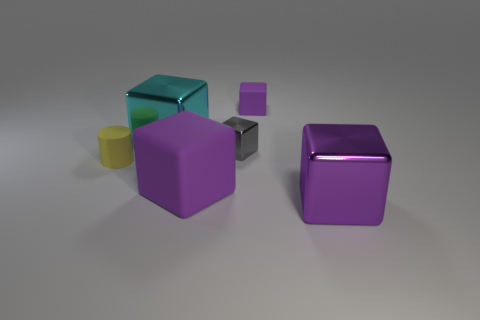Subtract all gray balls. How many purple blocks are left? 3 Subtract 2 cubes. How many cubes are left? 3 Subtract all cyan cubes. How many cubes are left? 4 Subtract all large matte blocks. How many blocks are left? 4 Subtract all brown cubes. Subtract all brown cylinders. How many cubes are left? 5 Add 1 large matte cubes. How many objects exist? 7 Subtract all blocks. How many objects are left? 1 Subtract 0 yellow blocks. How many objects are left? 6 Subtract all large blue rubber spheres. Subtract all blocks. How many objects are left? 1 Add 2 rubber objects. How many rubber objects are left? 5 